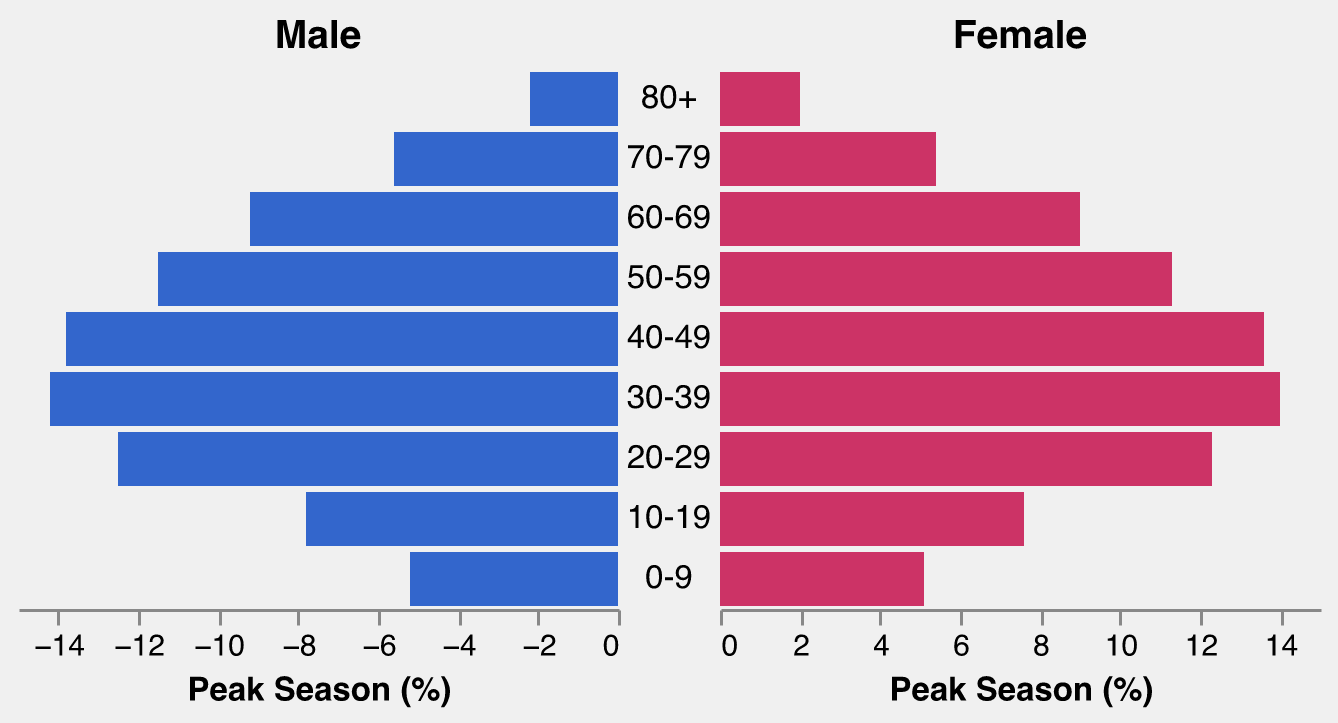what is the total percentage of male visitors in the 30-39 age group across both seasons? Add the percentage values for both Peak Season Male (14.2%) and Off-Peak Season Male (6.9%) for the 30-39 age group. The total is 14.2 + 6.9 = 21.1%
Answer: 21.1% Which age group has the highest percentage of male visitors during peak season? Compare the percentage of Peak Season Male visitors across all age groups. The age group 30-39 has the highest percentage with 14.2%.
Answer: 30-39 How much greater is the percentage of female visitors aged 50-59 during peak season compared to off-peak season? Subtract the percentage of Off-Peak Season Female (8.4%) from the Peak Season Female (11.3%) for the 50-59 age group. The difference is 11.3 - 8.4 = 2.9%.
Answer: 2.9% What is the age group with the smallest difference in percentage of female visitors between peak and off-peak seasons? Calculate the differences for each age group: (5.1 - 2.0 = 3.1, 7.6 - 3.1 = 4.5, 12.3 - 5.7 = 6.6, 14.0 - 6.8 = 7.2, 13.6 - 7.1 = 6.5, 11.3 - 8.4 = 2.9, 9.0 - 7.7 = 1.3, 5.4 - 4.8 = 0.6, 2.0 - 1.8 = 0.2). The smallest difference is for the 80+ age group with a difference of 0.2%.
Answer: 80+ Which gender has a higher percentage of visitors in the 20-29 age group during peak season? Compare the Peak Season Male (12.5%) and Peak Season Female (12.3%) percentages for the 20-29 age group. Male visitors have a higher percentage.
Answer: Male What's the average percentage of peak season female visitors across all age groups? Add up all the percentages for Peak Season Female and divide by the number of age groups: (5.1 + 7.6 + 12.3 + 14.0 + 13.6 + 11.3 + 9.0 + 5.4 + 2.0) / 9 = (80.3) / 9 ≈ 8.9%
Answer: 8.9% Is there any age group where the percentage of male visitors is higher during the off-peak season than during the peak season? Compare the Peak and Off-Peak Season Male percentages for each age group. None of the age groups have higher Off-Peak percentages than Peak percentages.
Answer: No What is the combined percentage of peak season visitors in the 40-49 and 50-59 age groups for both genders? Add up the Peak Season Male and Female percentages for both age groups: (13.8 + 13.6) + (11.5 + 11.3) = 27.4 + 22.8 = 50.2%
Answer: 50.2% Do female visitors aged 60-69 have a higher percentage during peak season or off-peak season? Compare the Peak Season Female (9.0%) and Off-Peak Season Female (7.7%) percentages for the 60-69 age group. Peak season has the higher percentage.
Answer: Peak season 